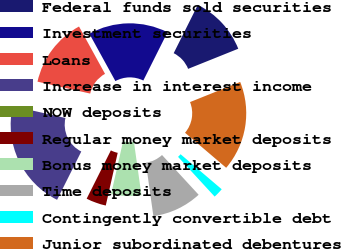<chart> <loc_0><loc_0><loc_500><loc_500><pie_chart><fcel>Federal funds sold securities<fcel>Investment securities<fcel>Loans<fcel>Increase in interest income<fcel>NOW deposits<fcel>Regular money market deposits<fcel>Bonus money market deposits<fcel>Time deposits<fcel>Contingently convertible debt<fcel>Junior subordinated debentures<nl><fcel>11.54%<fcel>15.38%<fcel>13.46%<fcel>21.15%<fcel>0.0%<fcel>3.85%<fcel>5.77%<fcel>9.62%<fcel>1.93%<fcel>17.3%<nl></chart> 